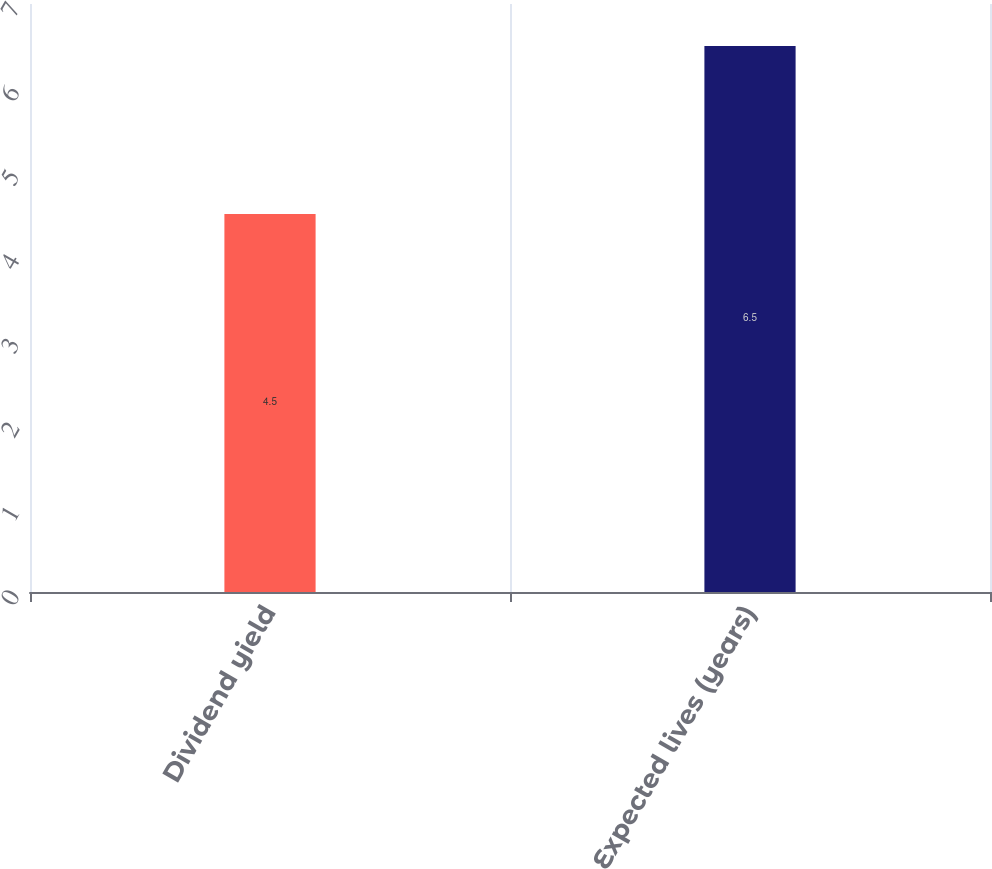Convert chart to OTSL. <chart><loc_0><loc_0><loc_500><loc_500><bar_chart><fcel>Dividend yield<fcel>Expected lives (years)<nl><fcel>4.5<fcel>6.5<nl></chart> 